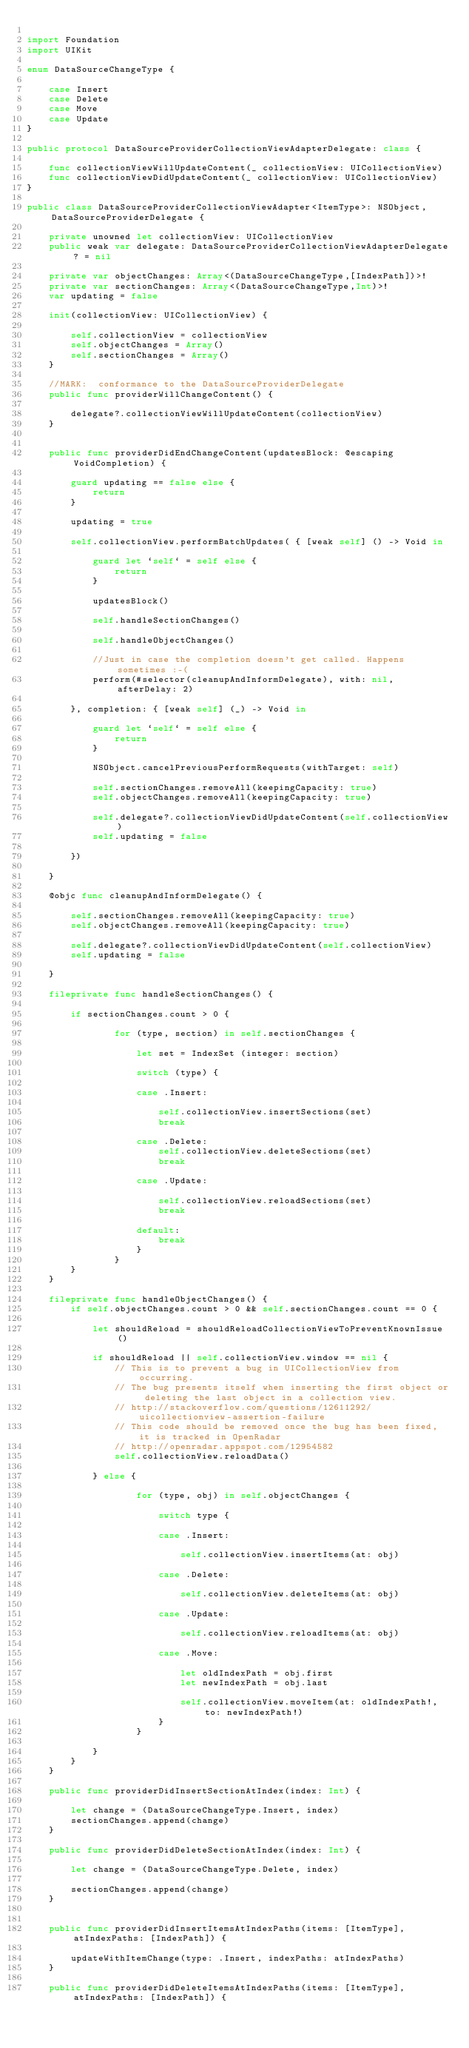<code> <loc_0><loc_0><loc_500><loc_500><_Swift_>
import Foundation
import UIKit

enum DataSourceChangeType {
    
    case Insert
    case Delete
    case Move
    case Update
}

public protocol DataSourceProviderCollectionViewAdapterDelegate: class {
        
    func collectionViewWillUpdateContent(_ collectionView: UICollectionView)
    func collectionViewDidUpdateContent(_ collectionView: UICollectionView)
}

public class DataSourceProviderCollectionViewAdapter<ItemType>: NSObject, DataSourceProviderDelegate {
    
    private unowned let collectionView: UICollectionView
    public weak var delegate: DataSourceProviderCollectionViewAdapterDelegate? = nil
    
    private var objectChanges: Array<(DataSourceChangeType,[IndexPath])>!
    private var sectionChanges: Array<(DataSourceChangeType,Int)>!
    var updating = false
    
    init(collectionView: UICollectionView) {
        
        self.collectionView = collectionView
        self.objectChanges = Array()
        self.sectionChanges = Array()
    }
    
    //MARK:  conformance to the DataSourceProviderDelegate
    public func providerWillChangeContent() {

        delegate?.collectionViewWillUpdateContent(collectionView)
    }

    
    public func providerDidEndChangeContent(updatesBlock: @escaping VoidCompletion) {

        guard updating == false else {
            return
        }
        
        updating = true

        self.collectionView.performBatchUpdates( { [weak self] () -> Void in

            guard let `self` = self else {
                return
            }
            
            updatesBlock()

            self.handleSectionChanges()

            self.handleObjectChanges()
            
            //Just in case the completion doesn't get called. Happens sometimes :-(
            perform(#selector(cleanupAndInformDelegate), with: nil, afterDelay: 2)

        }, completion: { [weak self] (_) -> Void in
                
            guard let `self` = self else {
                return
            }
                
            NSObject.cancelPreviousPerformRequests(withTarget: self)

            self.sectionChanges.removeAll(keepingCapacity: true)
            self.objectChanges.removeAll(keepingCapacity: true)
                
            self.delegate?.collectionViewDidUpdateContent(self.collectionView)
            self.updating = false
            
        })
        
    }
    
    @objc func cleanupAndInformDelegate() {
        
        self.sectionChanges.removeAll(keepingCapacity: true)
        self.objectChanges.removeAll(keepingCapacity: true)
                        
        self.delegate?.collectionViewDidUpdateContent(self.collectionView)
        self.updating = false
        
    }
    
    fileprivate func handleSectionChanges() {
        
        if sectionChanges.count > 0 {
            
                for (type, section) in self.sectionChanges {
                    
                    let set = IndexSet (integer: section)
                    
                    switch (type) {
                        
                    case .Insert:
                        
                        self.collectionView.insertSections(set)
                        break
                        
                    case .Delete:
                        self.collectionView.deleteSections(set)
                        break
                        
                    case .Update:
                        
                        self.collectionView.reloadSections(set)
                        break
                        
                    default:
                        break
                    }
                }
        }
    }
    
    fileprivate func handleObjectChanges() {
        if self.objectChanges.count > 0 && self.sectionChanges.count == 0 {
            
            let shouldReload = shouldReloadCollectionViewToPreventKnownIssue()
            
            if shouldReload || self.collectionView.window == nil {
                // This is to prevent a bug in UICollectionView from occurring.
                // The bug presents itself when inserting the first object or deleting the last object in a collection view.
                // http://stackoverflow.com/questions/12611292/uicollectionview-assertion-failure
                // This code should be removed once the bug has been fixed, it is tracked in OpenRadar
                // http://openradar.appspot.com/12954582
                self.collectionView.reloadData()
                
            } else {
                                    
                    for (type, obj) in self.objectChanges {
                        
                        switch type {
                            
                        case .Insert:
                            
                            self.collectionView.insertItems(at: obj)
                            
                        case .Delete:
                            
                            self.collectionView.deleteItems(at: obj)
                            
                        case .Update:
                            
                            self.collectionView.reloadItems(at: obj)
                            
                        case .Move:
                            
                            let oldIndexPath = obj.first
                            let newIndexPath = obj.last
                            
                            self.collectionView.moveItem(at: oldIndexPath!, to: newIndexPath!)
                        }
                    }

            }
        }
    }
    
    public func providerDidInsertSectionAtIndex(index: Int) {
        
        let change = (DataSourceChangeType.Insert, index)
        sectionChanges.append(change)
    }
    
    public func providerDidDeleteSectionAtIndex(index: Int) {
        
        let change = (DataSourceChangeType.Delete, index)
        
        sectionChanges.append(change)
    }
    
    
    public func providerDidInsertItemsAtIndexPaths(items: [ItemType], atIndexPaths: [IndexPath]) {
        
        updateWithItemChange(type: .Insert, indexPaths: atIndexPaths)
    }
    
    public func providerDidDeleteItemsAtIndexPaths(items: [ItemType], atIndexPaths: [IndexPath]) {
        
        </code> 